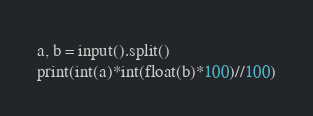<code> <loc_0><loc_0><loc_500><loc_500><_Python_>a, b = input().split()
print(int(a)*int(float(b)*100)//100)</code> 